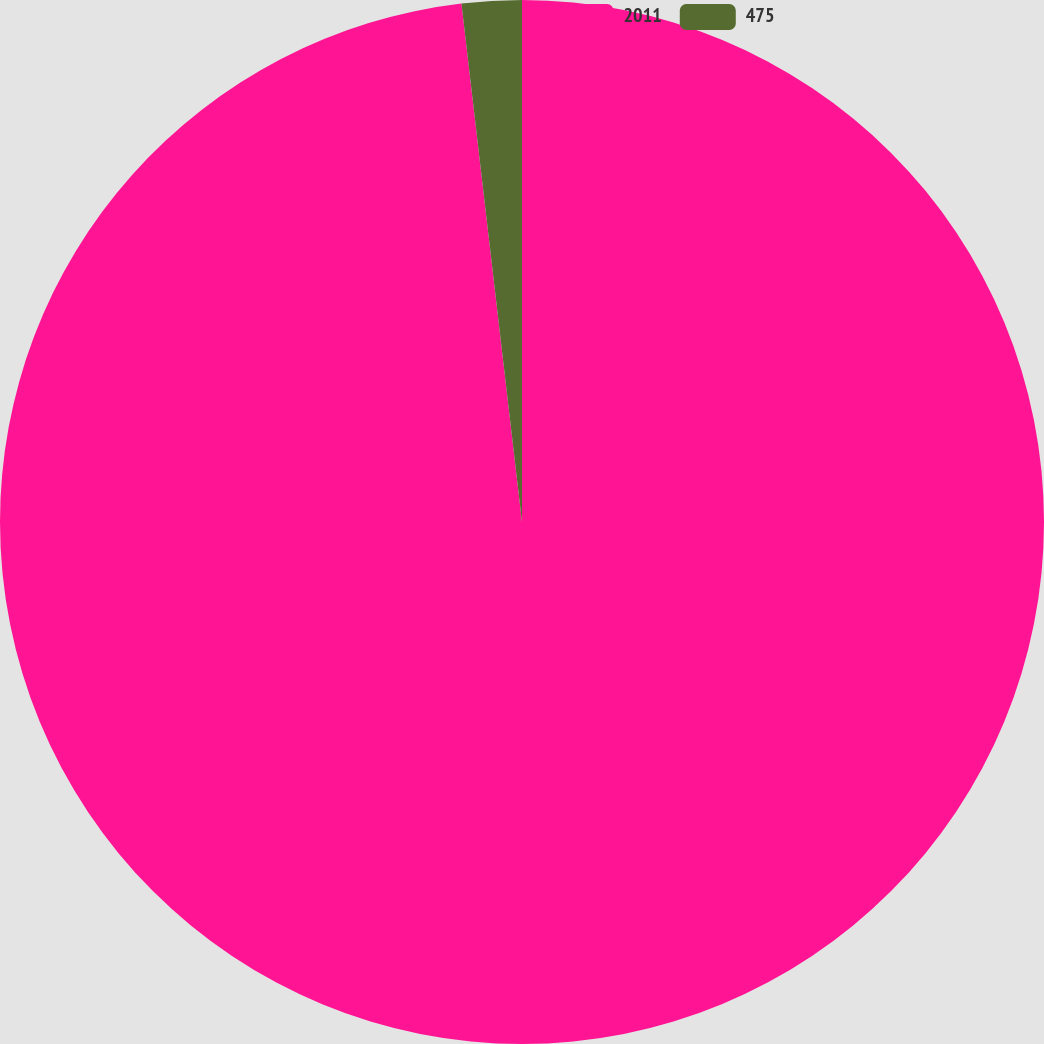Convert chart to OTSL. <chart><loc_0><loc_0><loc_500><loc_500><pie_chart><fcel>2011<fcel>475<nl><fcel>98.15%<fcel>1.85%<nl></chart> 